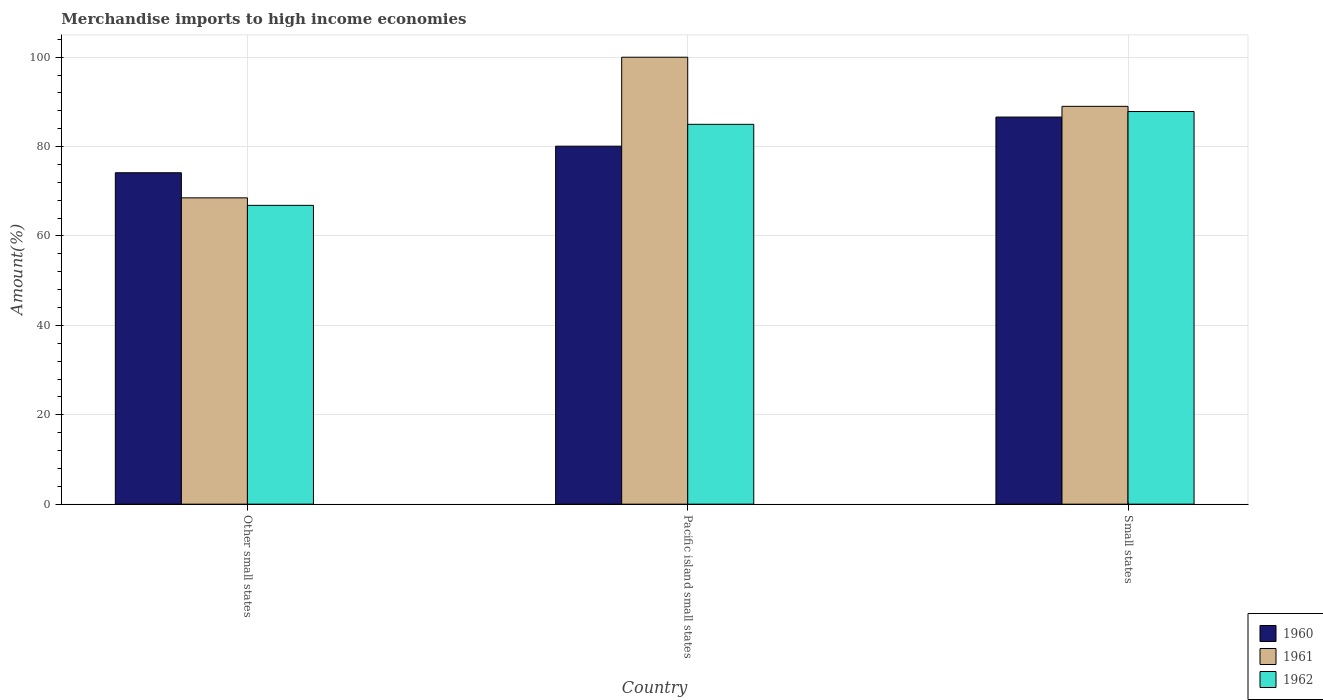How many different coloured bars are there?
Offer a very short reply. 3. Are the number of bars on each tick of the X-axis equal?
Provide a short and direct response. Yes. How many bars are there on the 1st tick from the left?
Your answer should be compact. 3. What is the label of the 2nd group of bars from the left?
Offer a terse response. Pacific island small states. What is the percentage of amount earned from merchandise imports in 1960 in Other small states?
Offer a very short reply. 74.15. Across all countries, what is the maximum percentage of amount earned from merchandise imports in 1961?
Make the answer very short. 100. Across all countries, what is the minimum percentage of amount earned from merchandise imports in 1962?
Offer a terse response. 66.86. In which country was the percentage of amount earned from merchandise imports in 1961 maximum?
Your answer should be compact. Pacific island small states. In which country was the percentage of amount earned from merchandise imports in 1962 minimum?
Your response must be concise. Other small states. What is the total percentage of amount earned from merchandise imports in 1960 in the graph?
Provide a short and direct response. 240.86. What is the difference between the percentage of amount earned from merchandise imports in 1962 in Other small states and that in Small states?
Your response must be concise. -20.99. What is the difference between the percentage of amount earned from merchandise imports in 1960 in Small states and the percentage of amount earned from merchandise imports in 1962 in Other small states?
Ensure brevity in your answer.  19.76. What is the average percentage of amount earned from merchandise imports in 1962 per country?
Offer a terse response. 79.9. What is the difference between the percentage of amount earned from merchandise imports of/in 1960 and percentage of amount earned from merchandise imports of/in 1961 in Other small states?
Provide a short and direct response. 5.62. In how many countries, is the percentage of amount earned from merchandise imports in 1960 greater than 12 %?
Keep it short and to the point. 3. What is the ratio of the percentage of amount earned from merchandise imports in 1960 in Other small states to that in Small states?
Provide a succinct answer. 0.86. Is the percentage of amount earned from merchandise imports in 1960 in Other small states less than that in Pacific island small states?
Your response must be concise. Yes. What is the difference between the highest and the second highest percentage of amount earned from merchandise imports in 1961?
Your answer should be very brief. -10.99. What is the difference between the highest and the lowest percentage of amount earned from merchandise imports in 1960?
Your response must be concise. 12.46. Are all the bars in the graph horizontal?
Offer a very short reply. No. Are the values on the major ticks of Y-axis written in scientific E-notation?
Provide a succinct answer. No. Does the graph contain any zero values?
Keep it short and to the point. No. Does the graph contain grids?
Make the answer very short. Yes. How many legend labels are there?
Offer a very short reply. 3. How are the legend labels stacked?
Your response must be concise. Vertical. What is the title of the graph?
Keep it short and to the point. Merchandise imports to high income economies. Does "1998" appear as one of the legend labels in the graph?
Offer a very short reply. No. What is the label or title of the X-axis?
Offer a very short reply. Country. What is the label or title of the Y-axis?
Offer a terse response. Amount(%). What is the Amount(%) in 1960 in Other small states?
Keep it short and to the point. 74.15. What is the Amount(%) in 1961 in Other small states?
Your response must be concise. 68.53. What is the Amount(%) in 1962 in Other small states?
Give a very brief answer. 66.86. What is the Amount(%) in 1960 in Pacific island small states?
Give a very brief answer. 80.1. What is the Amount(%) in 1961 in Pacific island small states?
Your answer should be compact. 100. What is the Amount(%) of 1962 in Pacific island small states?
Provide a short and direct response. 84.99. What is the Amount(%) in 1960 in Small states?
Your response must be concise. 86.61. What is the Amount(%) of 1961 in Small states?
Provide a succinct answer. 89.01. What is the Amount(%) of 1962 in Small states?
Provide a short and direct response. 87.85. Across all countries, what is the maximum Amount(%) in 1960?
Offer a very short reply. 86.61. Across all countries, what is the maximum Amount(%) in 1962?
Ensure brevity in your answer.  87.85. Across all countries, what is the minimum Amount(%) in 1960?
Make the answer very short. 74.15. Across all countries, what is the minimum Amount(%) in 1961?
Your response must be concise. 68.53. Across all countries, what is the minimum Amount(%) in 1962?
Offer a terse response. 66.86. What is the total Amount(%) of 1960 in the graph?
Make the answer very short. 240.86. What is the total Amount(%) in 1961 in the graph?
Offer a terse response. 257.55. What is the total Amount(%) in 1962 in the graph?
Keep it short and to the point. 239.7. What is the difference between the Amount(%) of 1960 in Other small states and that in Pacific island small states?
Make the answer very short. -5.95. What is the difference between the Amount(%) in 1961 in Other small states and that in Pacific island small states?
Offer a very short reply. -31.47. What is the difference between the Amount(%) of 1962 in Other small states and that in Pacific island small states?
Ensure brevity in your answer.  -18.13. What is the difference between the Amount(%) of 1960 in Other small states and that in Small states?
Your response must be concise. -12.46. What is the difference between the Amount(%) of 1961 in Other small states and that in Small states?
Ensure brevity in your answer.  -20.48. What is the difference between the Amount(%) in 1962 in Other small states and that in Small states?
Give a very brief answer. -20.99. What is the difference between the Amount(%) in 1960 in Pacific island small states and that in Small states?
Ensure brevity in your answer.  -6.52. What is the difference between the Amount(%) of 1961 in Pacific island small states and that in Small states?
Give a very brief answer. 10.99. What is the difference between the Amount(%) in 1962 in Pacific island small states and that in Small states?
Your response must be concise. -2.86. What is the difference between the Amount(%) in 1960 in Other small states and the Amount(%) in 1961 in Pacific island small states?
Keep it short and to the point. -25.85. What is the difference between the Amount(%) of 1960 in Other small states and the Amount(%) of 1962 in Pacific island small states?
Provide a succinct answer. -10.84. What is the difference between the Amount(%) of 1961 in Other small states and the Amount(%) of 1962 in Pacific island small states?
Make the answer very short. -16.45. What is the difference between the Amount(%) in 1960 in Other small states and the Amount(%) in 1961 in Small states?
Your answer should be compact. -14.86. What is the difference between the Amount(%) in 1960 in Other small states and the Amount(%) in 1962 in Small states?
Give a very brief answer. -13.7. What is the difference between the Amount(%) in 1961 in Other small states and the Amount(%) in 1962 in Small states?
Make the answer very short. -19.32. What is the difference between the Amount(%) in 1960 in Pacific island small states and the Amount(%) in 1961 in Small states?
Offer a terse response. -8.92. What is the difference between the Amount(%) of 1960 in Pacific island small states and the Amount(%) of 1962 in Small states?
Provide a short and direct response. -7.75. What is the difference between the Amount(%) of 1961 in Pacific island small states and the Amount(%) of 1962 in Small states?
Your response must be concise. 12.15. What is the average Amount(%) of 1960 per country?
Offer a very short reply. 80.29. What is the average Amount(%) of 1961 per country?
Offer a terse response. 85.85. What is the average Amount(%) of 1962 per country?
Offer a very short reply. 79.9. What is the difference between the Amount(%) of 1960 and Amount(%) of 1961 in Other small states?
Your answer should be compact. 5.62. What is the difference between the Amount(%) in 1960 and Amount(%) in 1962 in Other small states?
Offer a very short reply. 7.29. What is the difference between the Amount(%) of 1961 and Amount(%) of 1962 in Other small states?
Keep it short and to the point. 1.68. What is the difference between the Amount(%) in 1960 and Amount(%) in 1961 in Pacific island small states?
Provide a succinct answer. -19.9. What is the difference between the Amount(%) in 1960 and Amount(%) in 1962 in Pacific island small states?
Provide a succinct answer. -4.89. What is the difference between the Amount(%) in 1961 and Amount(%) in 1962 in Pacific island small states?
Your answer should be compact. 15.01. What is the difference between the Amount(%) of 1960 and Amount(%) of 1961 in Small states?
Ensure brevity in your answer.  -2.4. What is the difference between the Amount(%) in 1960 and Amount(%) in 1962 in Small states?
Give a very brief answer. -1.24. What is the difference between the Amount(%) in 1961 and Amount(%) in 1962 in Small states?
Your answer should be very brief. 1.16. What is the ratio of the Amount(%) in 1960 in Other small states to that in Pacific island small states?
Offer a terse response. 0.93. What is the ratio of the Amount(%) in 1961 in Other small states to that in Pacific island small states?
Ensure brevity in your answer.  0.69. What is the ratio of the Amount(%) in 1962 in Other small states to that in Pacific island small states?
Provide a short and direct response. 0.79. What is the ratio of the Amount(%) of 1960 in Other small states to that in Small states?
Provide a succinct answer. 0.86. What is the ratio of the Amount(%) of 1961 in Other small states to that in Small states?
Your answer should be very brief. 0.77. What is the ratio of the Amount(%) in 1962 in Other small states to that in Small states?
Offer a terse response. 0.76. What is the ratio of the Amount(%) in 1960 in Pacific island small states to that in Small states?
Provide a short and direct response. 0.92. What is the ratio of the Amount(%) in 1961 in Pacific island small states to that in Small states?
Your answer should be very brief. 1.12. What is the ratio of the Amount(%) of 1962 in Pacific island small states to that in Small states?
Your answer should be very brief. 0.97. What is the difference between the highest and the second highest Amount(%) of 1960?
Offer a very short reply. 6.52. What is the difference between the highest and the second highest Amount(%) of 1961?
Your response must be concise. 10.99. What is the difference between the highest and the second highest Amount(%) of 1962?
Give a very brief answer. 2.86. What is the difference between the highest and the lowest Amount(%) of 1960?
Ensure brevity in your answer.  12.46. What is the difference between the highest and the lowest Amount(%) of 1961?
Ensure brevity in your answer.  31.47. What is the difference between the highest and the lowest Amount(%) of 1962?
Provide a short and direct response. 20.99. 